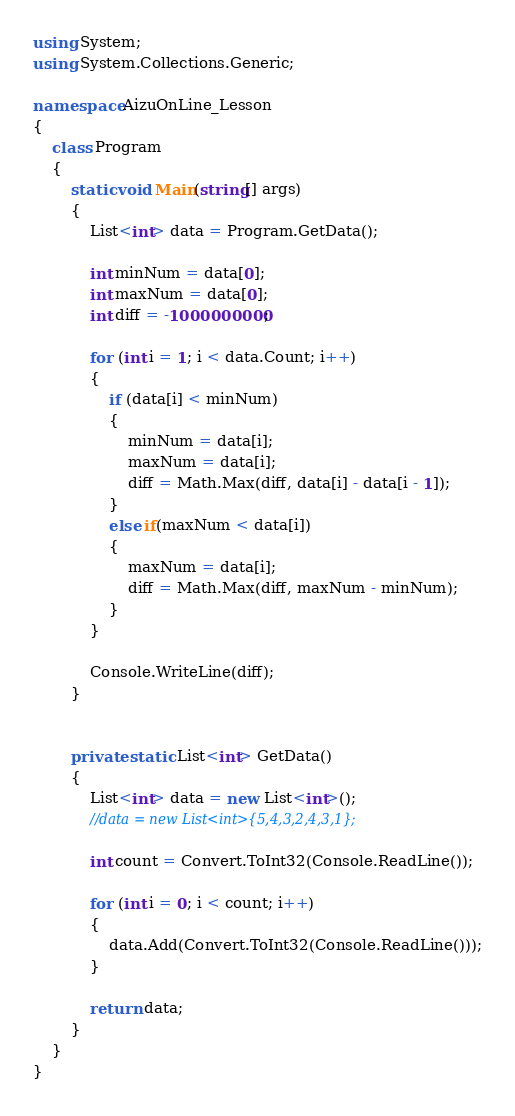Convert code to text. <code><loc_0><loc_0><loc_500><loc_500><_C#_>using System;
using System.Collections.Generic;

namespace AizuOnLine_Lesson
{
    class Program
    {
        static void Main(string[] args)
        {
            List<int> data = Program.GetData();

            int minNum = data[0];
            int maxNum = data[0];
            int diff = -1000000000;

            for (int i = 1; i < data.Count; i++)
            {
                if (data[i] < minNum)
                {
                    minNum = data[i];
                    maxNum = data[i];
                    diff = Math.Max(diff, data[i] - data[i - 1]);
                }
                else if(maxNum < data[i])
                {
                    maxNum = data[i];
                    diff = Math.Max(diff, maxNum - minNum);
                }
            }

            Console.WriteLine(diff);
        }


        private static List<int> GetData()
        {
            List<int> data = new List<int>();
            //data = new List<int>{5,4,3,2,4,3,1};

            int count = Convert.ToInt32(Console.ReadLine());

            for (int i = 0; i < count; i++)
            {
                data.Add(Convert.ToInt32(Console.ReadLine()));
            }

            return data;
        }
    }
}</code> 